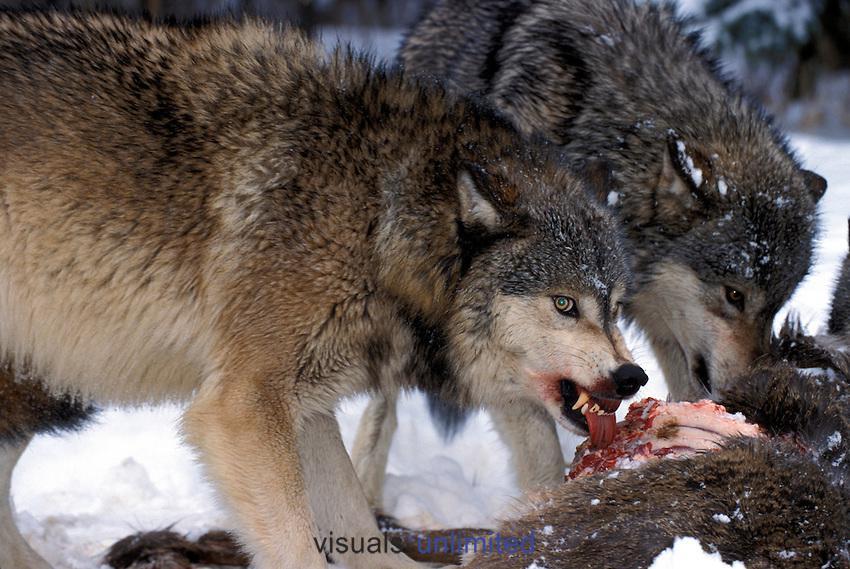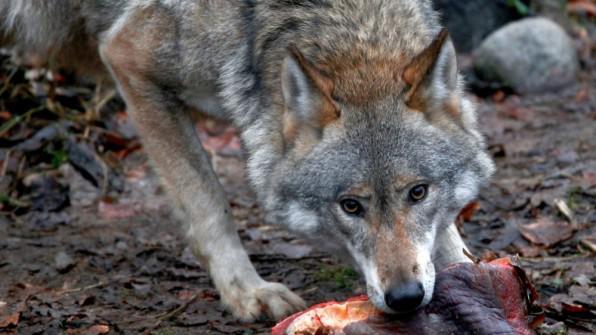The first image is the image on the left, the second image is the image on the right. Considering the images on both sides, is "There is no more than one wolf in the right image." valid? Answer yes or no. Yes. 